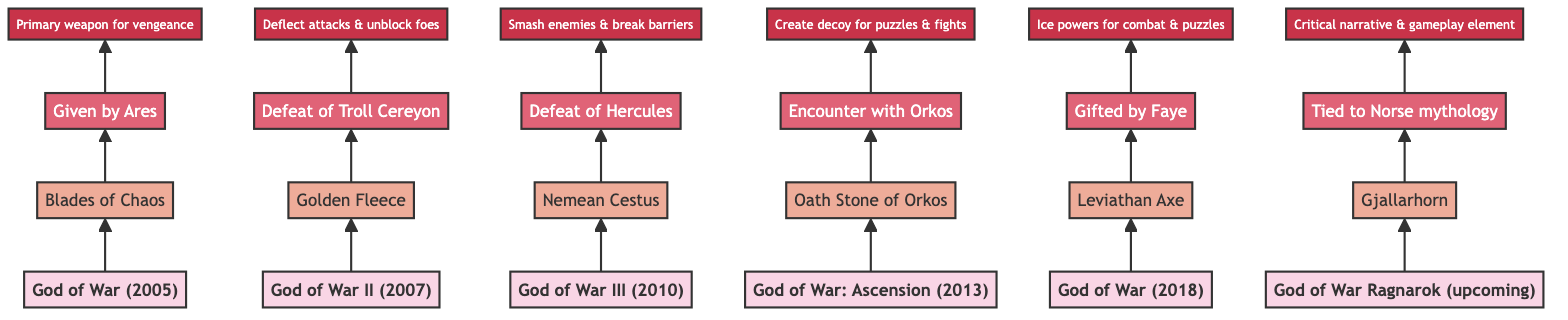What is the first artifact obtained in the God of War series? The diagram shows that the first artifact listed is "Blades of Chaos" from the game "God of War (2005)", which is at the bottom of the flow chart.
Answer: Blades of Chaos Which game features the artifact "Nemean Cestus"? By following the flow upwards, we see that "Nemean Cestus" is associated with "God of War III (2010)" in the diagram.
Answer: God of War III (2010) How does Kratos acquire the "Golden Fleece"? The flow shows that "Golden Fleece" is obtained through the "Defeat of Troll Cereyon", which is indicated in the method node pointing upwards from the artifact.
Answer: Defeat of the Troll Cereyon What does the "Oath Stone of Orkos" allow Kratos to do? The significance node associated with "Oath Stone of Orkos" states it allows Kratos to "Create decoy for puzzles & fights", indicating its primary usage in gameplay.
Answer: Create decoy for puzzles & fights In which game does Kratos receive the "Leviathan Axe", and from whom? The diagram indicates that "Leviathan Axe" is gifted by Faye in "God of War (2018)", which can be deduced by looking at the nodes showing the method and game.
Answer: Gifted by Faye in God of War (2018) What is the significance of the "Gjallarhorn"? The flowchart points to the significance of the "Gjallarhorn" as "Critical narrative & gameplay element", indicating its importance in the upcoming game.
Answer: Critical narrative & gameplay element Which artifact comes from defeating Hercules? The diagram clearly shows that the "Nemean Cestus" is obtained by defeating Hercules, as indicated by the connecting arrows and nodes.
Answer: Nemean Cestus How many artifacts are featured in this diagram? The diagram displays a total of six artifacts associated with different games, which can be counted from the artifact nodes.
Answer: Six Which artifact is attributed to being a primary weapon for vengeance? The significance node associated with "Blades of Chaos" labels it as the "Primary weapon for vengeance", directly linked to its story context.
Answer: Primary weapon for vengeance 